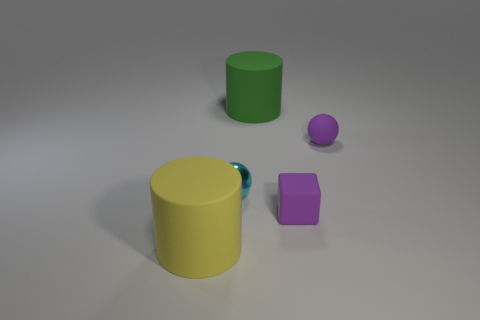Subtract all balls. How many objects are left? 3 Add 1 small purple rubber things. How many objects exist? 6 Subtract all purple matte balls. Subtract all yellow cylinders. How many objects are left? 3 Add 2 big green things. How many big green things are left? 3 Add 4 big cylinders. How many big cylinders exist? 6 Subtract all green cylinders. How many cylinders are left? 1 Subtract 0 gray cubes. How many objects are left? 5 Subtract 2 spheres. How many spheres are left? 0 Subtract all gray cubes. Subtract all green spheres. How many cubes are left? 1 Subtract all purple spheres. How many cyan cylinders are left? 0 